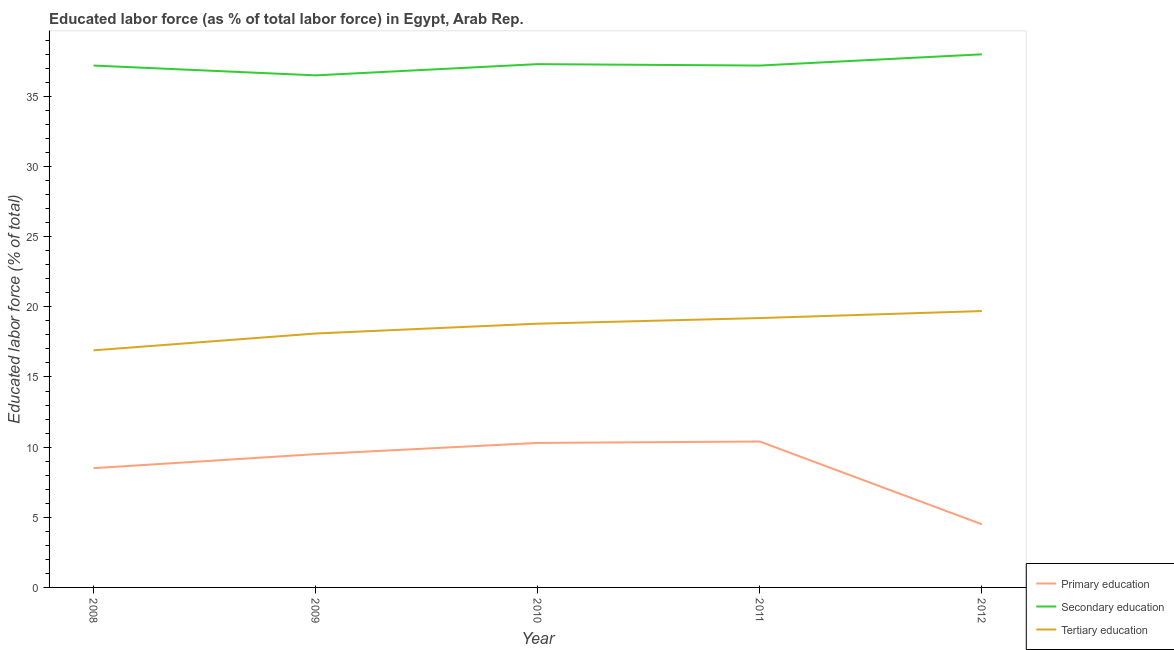Does the line corresponding to percentage of labor force who received secondary education intersect with the line corresponding to percentage of labor force who received primary education?
Provide a short and direct response. No. What is the percentage of labor force who received secondary education in 2009?
Offer a terse response. 36.5. Across all years, what is the minimum percentage of labor force who received secondary education?
Offer a very short reply. 36.5. In which year was the percentage of labor force who received secondary education minimum?
Your response must be concise. 2009. What is the total percentage of labor force who received primary education in the graph?
Offer a very short reply. 43.2. What is the difference between the percentage of labor force who received tertiary education in 2010 and that in 2011?
Offer a very short reply. -0.4. What is the difference between the percentage of labor force who received primary education in 2011 and the percentage of labor force who received tertiary education in 2009?
Offer a terse response. -7.7. What is the average percentage of labor force who received tertiary education per year?
Ensure brevity in your answer.  18.54. In the year 2010, what is the difference between the percentage of labor force who received tertiary education and percentage of labor force who received secondary education?
Keep it short and to the point. -18.5. What is the ratio of the percentage of labor force who received secondary education in 2011 to that in 2012?
Offer a terse response. 0.98. What is the difference between the highest and the second highest percentage of labor force who received tertiary education?
Ensure brevity in your answer.  0.5. What is the difference between the highest and the lowest percentage of labor force who received secondary education?
Offer a very short reply. 1.5. Is it the case that in every year, the sum of the percentage of labor force who received primary education and percentage of labor force who received secondary education is greater than the percentage of labor force who received tertiary education?
Your response must be concise. Yes. Does the percentage of labor force who received secondary education monotonically increase over the years?
Your response must be concise. No. Is the percentage of labor force who received primary education strictly greater than the percentage of labor force who received tertiary education over the years?
Provide a succinct answer. No. How many lines are there?
Give a very brief answer. 3. How many years are there in the graph?
Ensure brevity in your answer.  5. What is the difference between two consecutive major ticks on the Y-axis?
Your answer should be very brief. 5. Are the values on the major ticks of Y-axis written in scientific E-notation?
Your answer should be compact. No. How many legend labels are there?
Your answer should be very brief. 3. How are the legend labels stacked?
Provide a short and direct response. Vertical. What is the title of the graph?
Make the answer very short. Educated labor force (as % of total labor force) in Egypt, Arab Rep. What is the label or title of the X-axis?
Give a very brief answer. Year. What is the label or title of the Y-axis?
Your answer should be compact. Educated labor force (% of total). What is the Educated labor force (% of total) of Secondary education in 2008?
Ensure brevity in your answer.  37.2. What is the Educated labor force (% of total) in Tertiary education in 2008?
Your answer should be compact. 16.9. What is the Educated labor force (% of total) of Secondary education in 2009?
Offer a terse response. 36.5. What is the Educated labor force (% of total) in Tertiary education in 2009?
Make the answer very short. 18.1. What is the Educated labor force (% of total) of Primary education in 2010?
Your answer should be compact. 10.3. What is the Educated labor force (% of total) in Secondary education in 2010?
Make the answer very short. 37.3. What is the Educated labor force (% of total) of Tertiary education in 2010?
Keep it short and to the point. 18.8. What is the Educated labor force (% of total) of Primary education in 2011?
Offer a terse response. 10.4. What is the Educated labor force (% of total) of Secondary education in 2011?
Offer a very short reply. 37.2. What is the Educated labor force (% of total) of Tertiary education in 2011?
Ensure brevity in your answer.  19.2. What is the Educated labor force (% of total) in Primary education in 2012?
Give a very brief answer. 4.5. What is the Educated labor force (% of total) in Tertiary education in 2012?
Make the answer very short. 19.7. Across all years, what is the maximum Educated labor force (% of total) of Primary education?
Make the answer very short. 10.4. Across all years, what is the maximum Educated labor force (% of total) of Secondary education?
Give a very brief answer. 38. Across all years, what is the maximum Educated labor force (% of total) in Tertiary education?
Offer a terse response. 19.7. Across all years, what is the minimum Educated labor force (% of total) in Secondary education?
Keep it short and to the point. 36.5. Across all years, what is the minimum Educated labor force (% of total) of Tertiary education?
Ensure brevity in your answer.  16.9. What is the total Educated labor force (% of total) in Primary education in the graph?
Keep it short and to the point. 43.2. What is the total Educated labor force (% of total) of Secondary education in the graph?
Your response must be concise. 186.2. What is the total Educated labor force (% of total) in Tertiary education in the graph?
Make the answer very short. 92.7. What is the difference between the Educated labor force (% of total) in Primary education in 2008 and that in 2009?
Provide a short and direct response. -1. What is the difference between the Educated labor force (% of total) in Secondary education in 2008 and that in 2010?
Give a very brief answer. -0.1. What is the difference between the Educated labor force (% of total) in Primary education in 2008 and that in 2011?
Provide a succinct answer. -1.9. What is the difference between the Educated labor force (% of total) of Secondary education in 2008 and that in 2011?
Your answer should be compact. 0. What is the difference between the Educated labor force (% of total) of Secondary education in 2008 and that in 2012?
Ensure brevity in your answer.  -0.8. What is the difference between the Educated labor force (% of total) of Tertiary education in 2008 and that in 2012?
Your answer should be very brief. -2.8. What is the difference between the Educated labor force (% of total) of Secondary education in 2009 and that in 2010?
Make the answer very short. -0.8. What is the difference between the Educated labor force (% of total) of Primary education in 2009 and that in 2011?
Offer a terse response. -0.9. What is the difference between the Educated labor force (% of total) in Secondary education in 2009 and that in 2011?
Ensure brevity in your answer.  -0.7. What is the difference between the Educated labor force (% of total) of Secondary education in 2009 and that in 2012?
Provide a succinct answer. -1.5. What is the difference between the Educated labor force (% of total) in Secondary education in 2010 and that in 2011?
Make the answer very short. 0.1. What is the difference between the Educated labor force (% of total) in Primary education in 2010 and that in 2012?
Your response must be concise. 5.8. What is the difference between the Educated labor force (% of total) in Secondary education in 2010 and that in 2012?
Ensure brevity in your answer.  -0.7. What is the difference between the Educated labor force (% of total) in Tertiary education in 2010 and that in 2012?
Offer a very short reply. -0.9. What is the difference between the Educated labor force (% of total) of Secondary education in 2011 and that in 2012?
Provide a succinct answer. -0.8. What is the difference between the Educated labor force (% of total) of Primary education in 2008 and the Educated labor force (% of total) of Secondary education in 2009?
Offer a terse response. -28. What is the difference between the Educated labor force (% of total) in Primary education in 2008 and the Educated labor force (% of total) in Tertiary education in 2009?
Give a very brief answer. -9.6. What is the difference between the Educated labor force (% of total) in Secondary education in 2008 and the Educated labor force (% of total) in Tertiary education in 2009?
Your answer should be very brief. 19.1. What is the difference between the Educated labor force (% of total) in Primary education in 2008 and the Educated labor force (% of total) in Secondary education in 2010?
Give a very brief answer. -28.8. What is the difference between the Educated labor force (% of total) of Primary education in 2008 and the Educated labor force (% of total) of Tertiary education in 2010?
Offer a terse response. -10.3. What is the difference between the Educated labor force (% of total) of Primary education in 2008 and the Educated labor force (% of total) of Secondary education in 2011?
Keep it short and to the point. -28.7. What is the difference between the Educated labor force (% of total) of Primary education in 2008 and the Educated labor force (% of total) of Tertiary education in 2011?
Make the answer very short. -10.7. What is the difference between the Educated labor force (% of total) of Primary education in 2008 and the Educated labor force (% of total) of Secondary education in 2012?
Make the answer very short. -29.5. What is the difference between the Educated labor force (% of total) in Primary education in 2008 and the Educated labor force (% of total) in Tertiary education in 2012?
Ensure brevity in your answer.  -11.2. What is the difference between the Educated labor force (% of total) of Secondary education in 2008 and the Educated labor force (% of total) of Tertiary education in 2012?
Offer a very short reply. 17.5. What is the difference between the Educated labor force (% of total) in Primary education in 2009 and the Educated labor force (% of total) in Secondary education in 2010?
Your answer should be very brief. -27.8. What is the difference between the Educated labor force (% of total) in Primary education in 2009 and the Educated labor force (% of total) in Secondary education in 2011?
Give a very brief answer. -27.7. What is the difference between the Educated labor force (% of total) of Primary education in 2009 and the Educated labor force (% of total) of Tertiary education in 2011?
Keep it short and to the point. -9.7. What is the difference between the Educated labor force (% of total) in Primary education in 2009 and the Educated labor force (% of total) in Secondary education in 2012?
Offer a terse response. -28.5. What is the difference between the Educated labor force (% of total) of Primary education in 2009 and the Educated labor force (% of total) of Tertiary education in 2012?
Your answer should be very brief. -10.2. What is the difference between the Educated labor force (% of total) in Secondary education in 2009 and the Educated labor force (% of total) in Tertiary education in 2012?
Your answer should be very brief. 16.8. What is the difference between the Educated labor force (% of total) in Primary education in 2010 and the Educated labor force (% of total) in Secondary education in 2011?
Provide a short and direct response. -26.9. What is the difference between the Educated labor force (% of total) of Primary education in 2010 and the Educated labor force (% of total) of Secondary education in 2012?
Give a very brief answer. -27.7. What is the difference between the Educated labor force (% of total) of Primary education in 2011 and the Educated labor force (% of total) of Secondary education in 2012?
Ensure brevity in your answer.  -27.6. What is the difference between the Educated labor force (% of total) of Secondary education in 2011 and the Educated labor force (% of total) of Tertiary education in 2012?
Give a very brief answer. 17.5. What is the average Educated labor force (% of total) in Primary education per year?
Provide a succinct answer. 8.64. What is the average Educated labor force (% of total) in Secondary education per year?
Give a very brief answer. 37.24. What is the average Educated labor force (% of total) in Tertiary education per year?
Ensure brevity in your answer.  18.54. In the year 2008, what is the difference between the Educated labor force (% of total) in Primary education and Educated labor force (% of total) in Secondary education?
Make the answer very short. -28.7. In the year 2008, what is the difference between the Educated labor force (% of total) in Primary education and Educated labor force (% of total) in Tertiary education?
Keep it short and to the point. -8.4. In the year 2008, what is the difference between the Educated labor force (% of total) in Secondary education and Educated labor force (% of total) in Tertiary education?
Your answer should be very brief. 20.3. In the year 2009, what is the difference between the Educated labor force (% of total) in Primary education and Educated labor force (% of total) in Tertiary education?
Make the answer very short. -8.6. In the year 2010, what is the difference between the Educated labor force (% of total) of Primary education and Educated labor force (% of total) of Secondary education?
Keep it short and to the point. -27. In the year 2010, what is the difference between the Educated labor force (% of total) in Primary education and Educated labor force (% of total) in Tertiary education?
Your answer should be compact. -8.5. In the year 2010, what is the difference between the Educated labor force (% of total) of Secondary education and Educated labor force (% of total) of Tertiary education?
Ensure brevity in your answer.  18.5. In the year 2011, what is the difference between the Educated labor force (% of total) in Primary education and Educated labor force (% of total) in Secondary education?
Provide a succinct answer. -26.8. In the year 2011, what is the difference between the Educated labor force (% of total) in Secondary education and Educated labor force (% of total) in Tertiary education?
Keep it short and to the point. 18. In the year 2012, what is the difference between the Educated labor force (% of total) in Primary education and Educated labor force (% of total) in Secondary education?
Provide a succinct answer. -33.5. In the year 2012, what is the difference between the Educated labor force (% of total) of Primary education and Educated labor force (% of total) of Tertiary education?
Your answer should be very brief. -15.2. What is the ratio of the Educated labor force (% of total) in Primary education in 2008 to that in 2009?
Provide a succinct answer. 0.89. What is the ratio of the Educated labor force (% of total) of Secondary education in 2008 to that in 2009?
Ensure brevity in your answer.  1.02. What is the ratio of the Educated labor force (% of total) of Tertiary education in 2008 to that in 2009?
Make the answer very short. 0.93. What is the ratio of the Educated labor force (% of total) in Primary education in 2008 to that in 2010?
Ensure brevity in your answer.  0.83. What is the ratio of the Educated labor force (% of total) in Secondary education in 2008 to that in 2010?
Give a very brief answer. 1. What is the ratio of the Educated labor force (% of total) of Tertiary education in 2008 to that in 2010?
Keep it short and to the point. 0.9. What is the ratio of the Educated labor force (% of total) of Primary education in 2008 to that in 2011?
Provide a short and direct response. 0.82. What is the ratio of the Educated labor force (% of total) of Tertiary education in 2008 to that in 2011?
Keep it short and to the point. 0.88. What is the ratio of the Educated labor force (% of total) of Primary education in 2008 to that in 2012?
Offer a very short reply. 1.89. What is the ratio of the Educated labor force (% of total) of Secondary education in 2008 to that in 2012?
Your response must be concise. 0.98. What is the ratio of the Educated labor force (% of total) of Tertiary education in 2008 to that in 2012?
Your answer should be very brief. 0.86. What is the ratio of the Educated labor force (% of total) of Primary education in 2009 to that in 2010?
Your response must be concise. 0.92. What is the ratio of the Educated labor force (% of total) of Secondary education in 2009 to that in 2010?
Give a very brief answer. 0.98. What is the ratio of the Educated labor force (% of total) in Tertiary education in 2009 to that in 2010?
Offer a very short reply. 0.96. What is the ratio of the Educated labor force (% of total) of Primary education in 2009 to that in 2011?
Give a very brief answer. 0.91. What is the ratio of the Educated labor force (% of total) of Secondary education in 2009 to that in 2011?
Make the answer very short. 0.98. What is the ratio of the Educated labor force (% of total) of Tertiary education in 2009 to that in 2011?
Provide a short and direct response. 0.94. What is the ratio of the Educated labor force (% of total) of Primary education in 2009 to that in 2012?
Offer a very short reply. 2.11. What is the ratio of the Educated labor force (% of total) of Secondary education in 2009 to that in 2012?
Offer a terse response. 0.96. What is the ratio of the Educated labor force (% of total) of Tertiary education in 2009 to that in 2012?
Provide a short and direct response. 0.92. What is the ratio of the Educated labor force (% of total) in Secondary education in 2010 to that in 2011?
Your response must be concise. 1. What is the ratio of the Educated labor force (% of total) in Tertiary education in 2010 to that in 2011?
Make the answer very short. 0.98. What is the ratio of the Educated labor force (% of total) of Primary education in 2010 to that in 2012?
Make the answer very short. 2.29. What is the ratio of the Educated labor force (% of total) in Secondary education in 2010 to that in 2012?
Offer a very short reply. 0.98. What is the ratio of the Educated labor force (% of total) in Tertiary education in 2010 to that in 2012?
Make the answer very short. 0.95. What is the ratio of the Educated labor force (% of total) in Primary education in 2011 to that in 2012?
Offer a terse response. 2.31. What is the ratio of the Educated labor force (% of total) in Secondary education in 2011 to that in 2012?
Give a very brief answer. 0.98. What is the ratio of the Educated labor force (% of total) of Tertiary education in 2011 to that in 2012?
Keep it short and to the point. 0.97. What is the difference between the highest and the second highest Educated labor force (% of total) of Secondary education?
Offer a very short reply. 0.7. What is the difference between the highest and the lowest Educated labor force (% of total) of Primary education?
Offer a terse response. 5.9. 